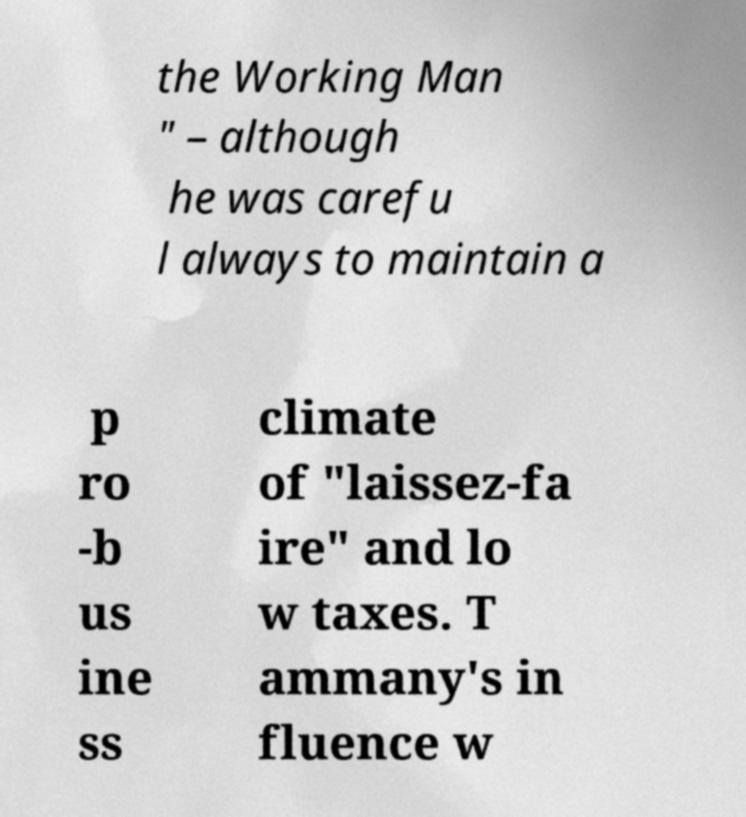Can you accurately transcribe the text from the provided image for me? the Working Man " – although he was carefu l always to maintain a p ro -b us ine ss climate of "laissez-fa ire" and lo w taxes. T ammany's in fluence w 